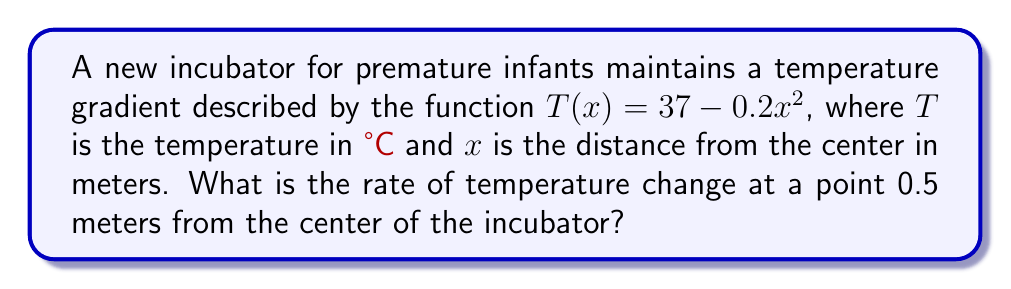What is the answer to this math problem? To find the rate of temperature change, we need to calculate the derivative of the temperature function T(x) with respect to x.

1) The given temperature function is:
   $T(x) = 37 - 0.2x^2$

2) To find the rate of change, we differentiate T(x) with respect to x:
   $\frac{dT}{dx} = -0.4x$

3) This derivative represents the temperature gradient or rate of temperature change at any point x.

4) We're asked to find the rate of change at x = 0.5 meters:
   $\frac{dT}{dx}|_{x=0.5} = -0.4(0.5) = -0.2$

5) The negative sign indicates that the temperature is decreasing as we move away from the center.

6) The units of this rate are °C/m (degrees Celsius per meter).
Answer: $-0.2$ °C/m 